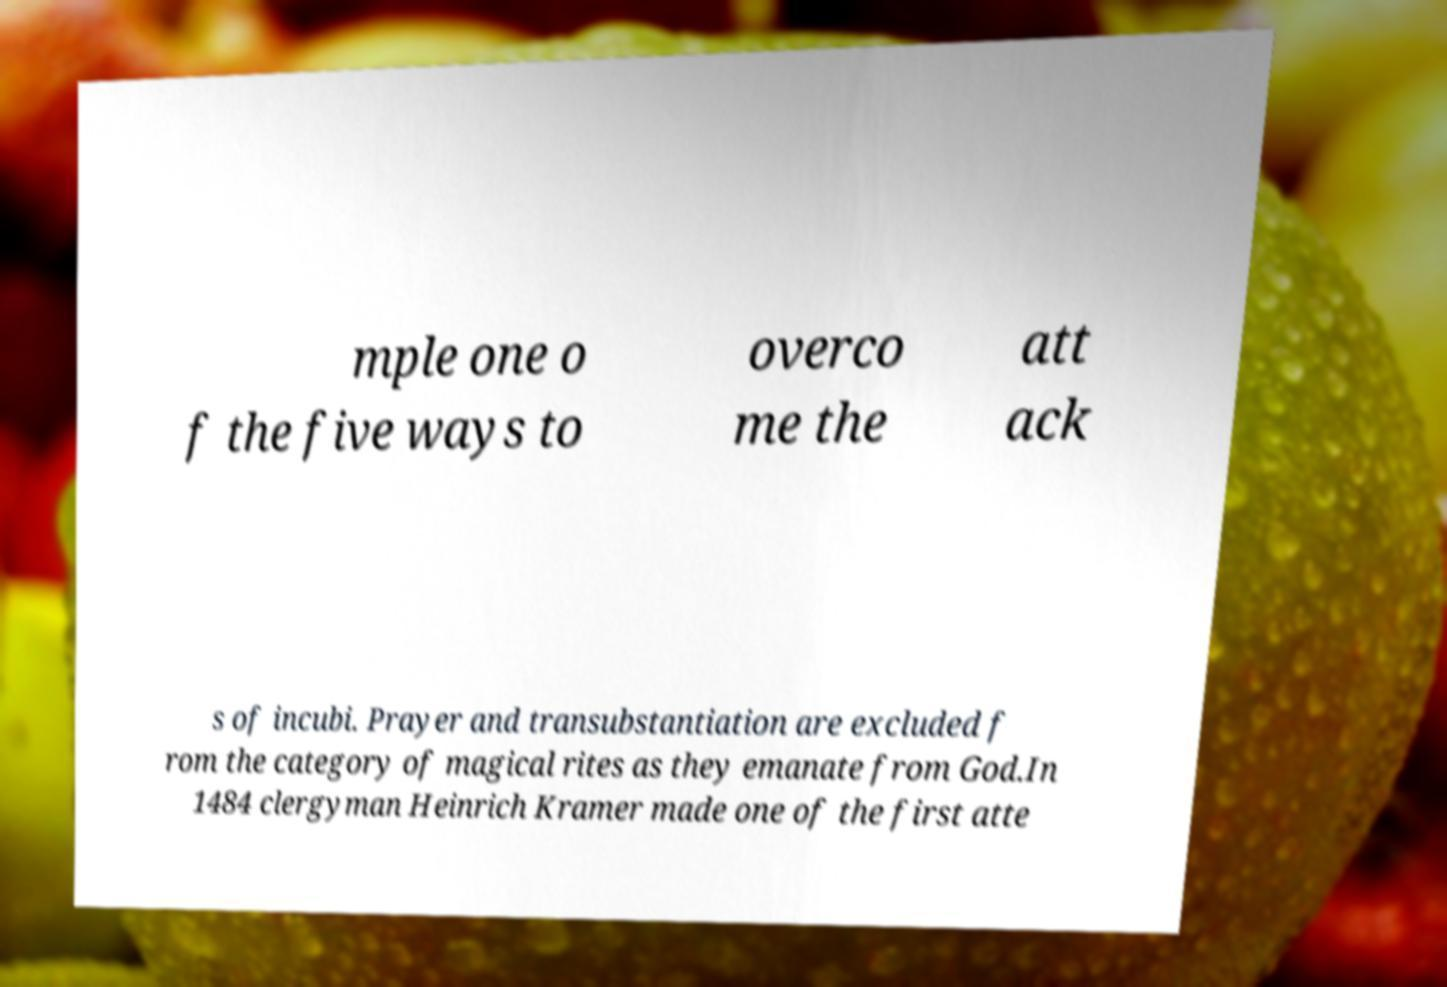I need the written content from this picture converted into text. Can you do that? mple one o f the five ways to overco me the att ack s of incubi. Prayer and transubstantiation are excluded f rom the category of magical rites as they emanate from God.In 1484 clergyman Heinrich Kramer made one of the first atte 